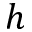<formula> <loc_0><loc_0><loc_500><loc_500>h</formula> 